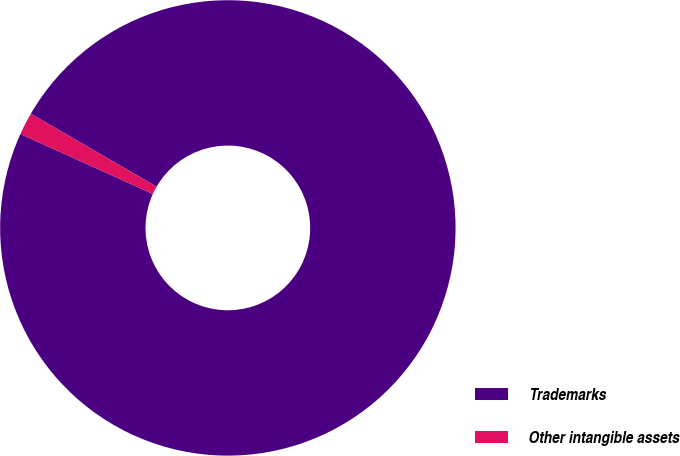Convert chart to OTSL. <chart><loc_0><loc_0><loc_500><loc_500><pie_chart><fcel>Trademarks<fcel>Other intangible assets<nl><fcel>98.41%<fcel>1.59%<nl></chart> 